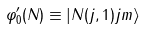<formula> <loc_0><loc_0><loc_500><loc_500>\varphi ^ { \prime } _ { 0 } ( N ) \equiv \left | N ( j , 1 ) j m \right \rangle</formula> 